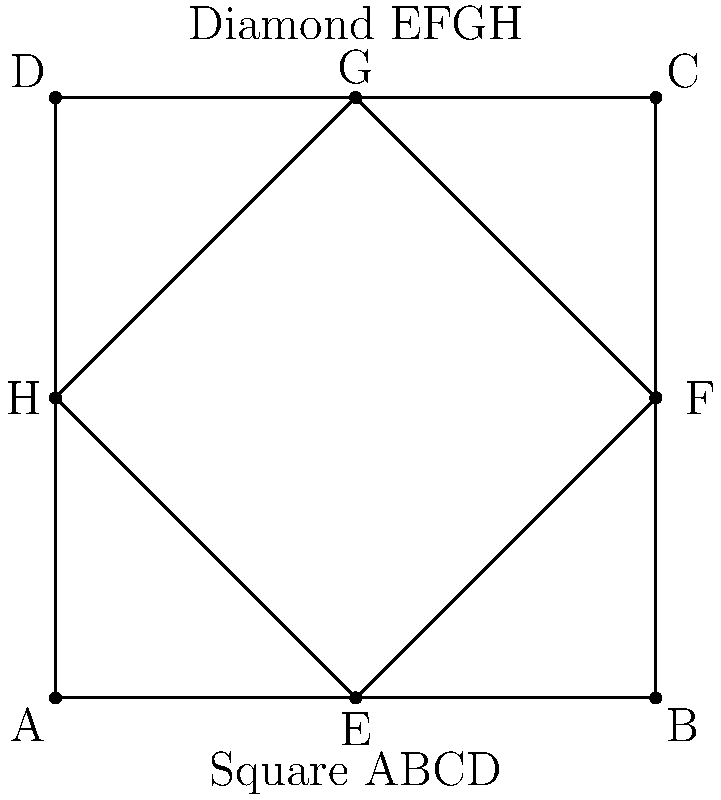In the geometric pattern shown, a diamond is inscribed within a square. If the area of the square is 16 square units, what is the area of the diamond? Let's approach this step-by-step:

1) First, we need to understand the relationship between the square and the diamond:
   - The diamond's corners touch the midpoints of the square's sides.

2) Given information:
   - Area of the square = 16 square units
   
3) Let's find the side length of the square:
   - Area of square = side^2
   - 16 = side^2
   - side = $\sqrt{16} = 4$ units

4) Now, let's consider the diamond:
   - Its diagonals are equal to the side length of the square.
   - Both diagonals = 4 units

5) The formula for the area of a diamond (or rhombus) is:
   $A = \frac{1}{2} \times d_1 \times d_2$
   Where $d_1$ and $d_2$ are the lengths of the diagonals

6) Plugging in our values:
   $A = \frac{1}{2} \times 4 \times 4 = 8$ square units

Therefore, the area of the diamond is 8 square units.
Answer: 8 square units 